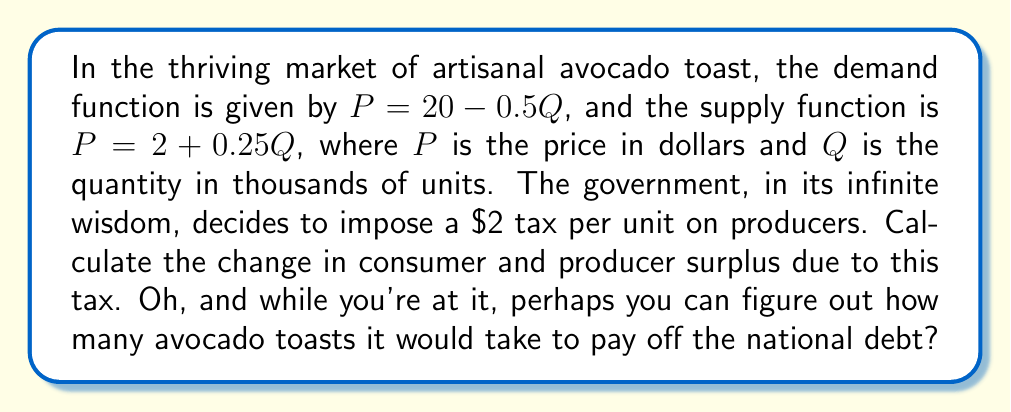Can you answer this question? Let's approach this problem step-by-step, shall we? After all, we economists love our steps almost as much as we love our avocado toast.

1) First, let's find the equilibrium price and quantity before the tax:
   
   Equate demand and supply: $20 - 0.5Q = 2 + 0.25Q$
   $18 = 0.75Q$
   $Q = 24$ thousand units
   
   Substituting back: $P = 20 - 0.5(24) = $8 per unit

2) Now, let's find the new equilibrium after the $2 tax:
   
   New supply function: $P = 4 + 0.25Q$ (adding $2 to the y-intercept)
   
   Equate new supply with demand: $20 - 0.5Q = 4 + 0.25Q$
   $16 = 0.75Q$
   $Q = 21.33$ thousand units
   
   New consumer price: $P_c = 20 - 0.5(21.33) = $9.33
   New producer price: $P_p = 9.33 - 2 = $7.33

3) Calculate consumer surplus (CS) before and after tax:
   
   CS before = $\frac{1}{2}(20-8)(24) = $144 thousand
   CS after = $\frac{1}{2}(20-9.33)(21.33) = $113.78 thousand
   Change in CS = $113.78 - $144 = -$30.22 thousand

4) Calculate producer surplus (PS) before and after tax:
   
   PS before = $\frac{1}{2}(8-2)(24) = $72 thousand
   PS after = $\frac{1}{2}(7.33-4)(21.33) = $35.55 thousand
   Change in PS = $35.55 - $72 = -$36.45 thousand

5) Total change in surplus:
   
   -$30.22 thousand - $36.45 thousand = -$66.67 thousand

As for paying off the national debt with avocado toast, well, at current prices, we'd need about 31.6 trillion avocado toasts. I'm sure our artisanal toast makers are up for the challenge!
Answer: The change in consumer surplus is -$30,220, and the change in producer surplus is -$36,450, resulting in a total decrease in economic surplus of $66,670. 